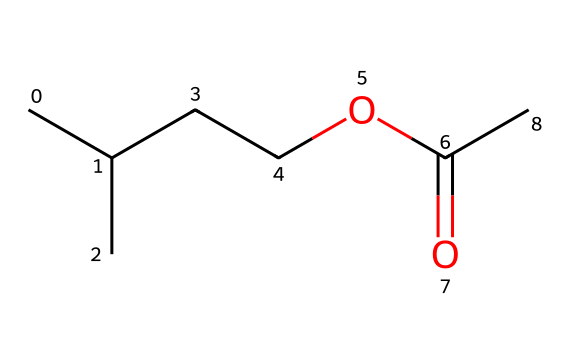What is the total number of carbon atoms in isoamyl acetate? The structural formula shows that there are five carbon atoms in the straight-chain portion (CC(C)CC) and one carbon atom in the acetate group (C(=O)C), totaling six carbon atoms.
Answer: 6 How many oxygen atoms are present in isoamyl acetate? In the SMILES representation, the structure has one carbonyl oxygen (C(=O)) and one ether oxygen (OC), which totals two oxygen atoms.
Answer: 2 What type of functional group is present in isoamyl acetate? The molecule contains an ester functional group, which can be recognized by the carbonyl (C=O) and ether (OC) components present in the structure.
Answer: ester How many hydrogen atoms are connected to the carbon atoms in isoamyl acetate? The total number of hydrogen atoms can be calculated by completing the tetravalent nature of carbon. There are 12 hydrogen atoms in total attached to the five carbon atoms.
Answer: 12 Which part of the structure indicates it has a fruity aroma? The ester functional group, specifically the arrangement of the carbon chain and the oxygen, contributes to the characteristic fruity aroma of isoamyl acetate.
Answer: ester group What is the molecular formula of isoamyl acetate? By counting the atoms from the SMILES, we find 6 carbons, 12 hydrogens, and 2 oxygens, leading to the molecular formula C6H12O2.
Answer: C6H12O2 